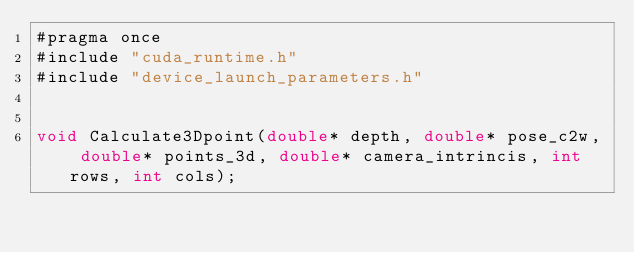Convert code to text. <code><loc_0><loc_0><loc_500><loc_500><_Cuda_>#pragma once
#include "cuda_runtime.h"
#include "device_launch_parameters.h"


void Calculate3Dpoint(double* depth, double* pose_c2w, double* points_3d, double* camera_intrincis, int rows, int cols);
</code> 